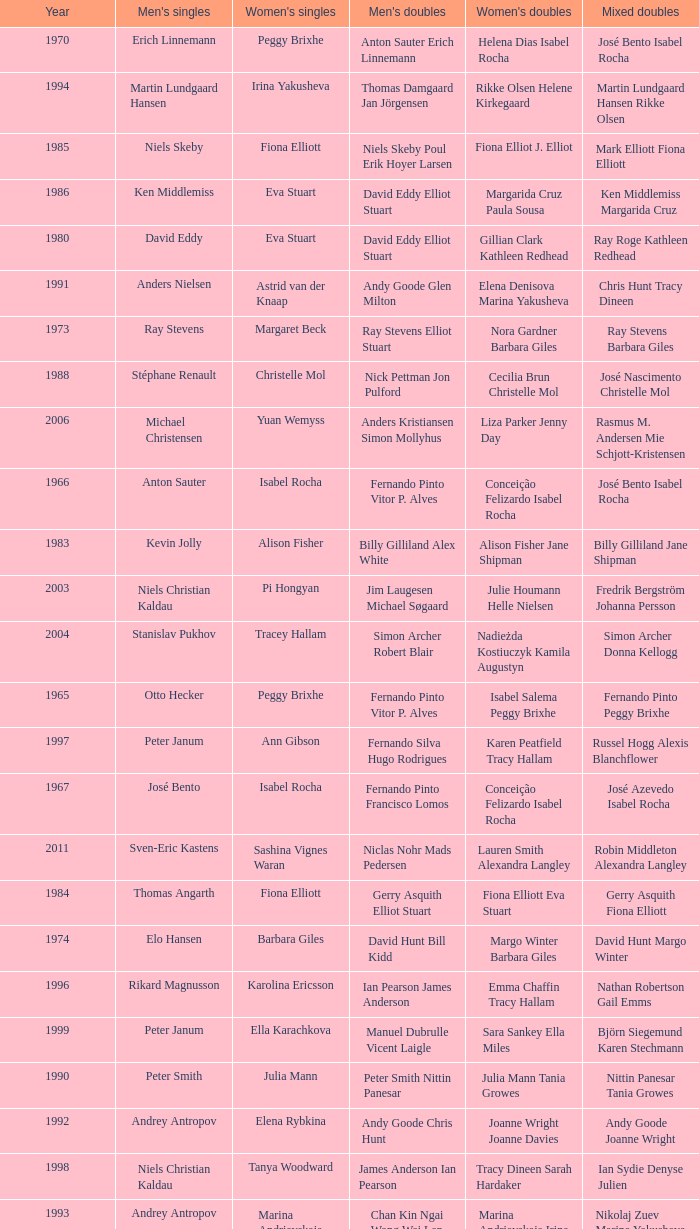What is the average year with alfredo salazar fina salazar in mixed doubles? 1971.0. 